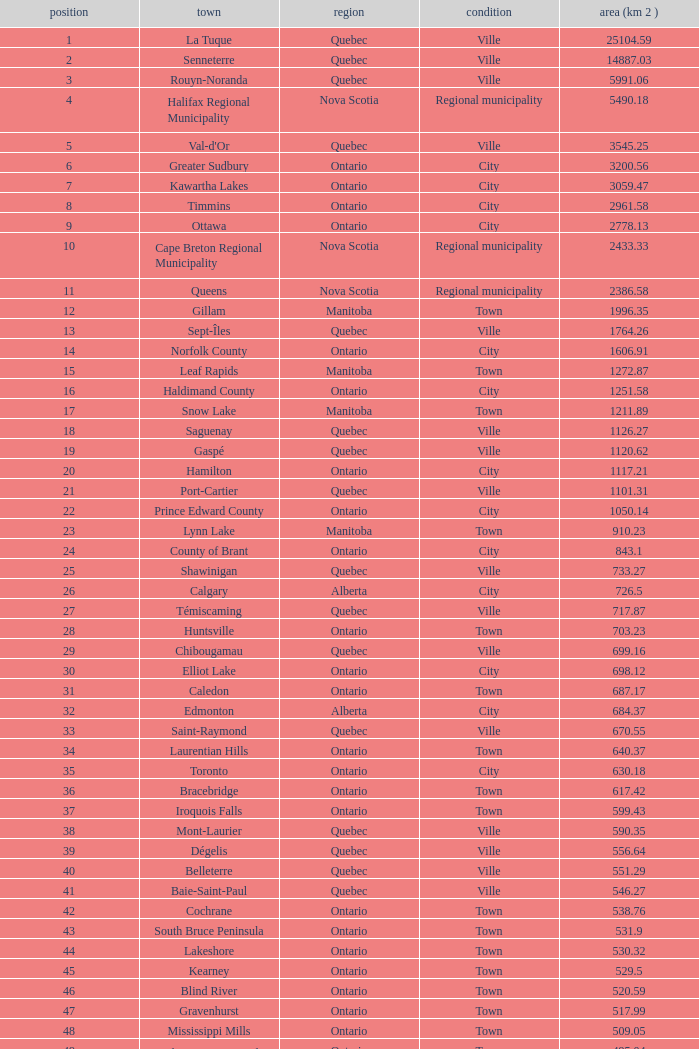What's the total of Rank that has an Area (KM 2) of 1050.14? 22.0. 